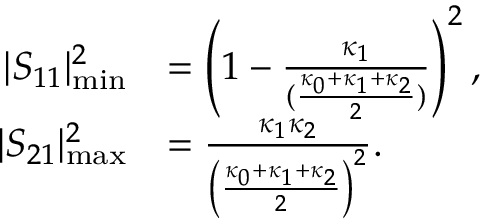Convert formula to latex. <formula><loc_0><loc_0><loc_500><loc_500>\begin{array} { r l } { | S _ { 1 1 } | _ { \min } ^ { 2 } } & { = \left ( 1 - \frac { \kappa _ { 1 } } { ( \frac { \kappa _ { 0 } + \kappa _ { 1 } + \kappa _ { 2 } } { 2 } ) } \right ) ^ { 2 } , } \\ { | S _ { 2 1 } | _ { \max } ^ { 2 } } & { = \frac { \kappa _ { 1 } \kappa _ { 2 } } { \left ( \frac { \kappa _ { 0 } + \kappa _ { 1 } + \kappa _ { 2 } } { 2 } \right ) ^ { 2 } } . } \end{array}</formula> 